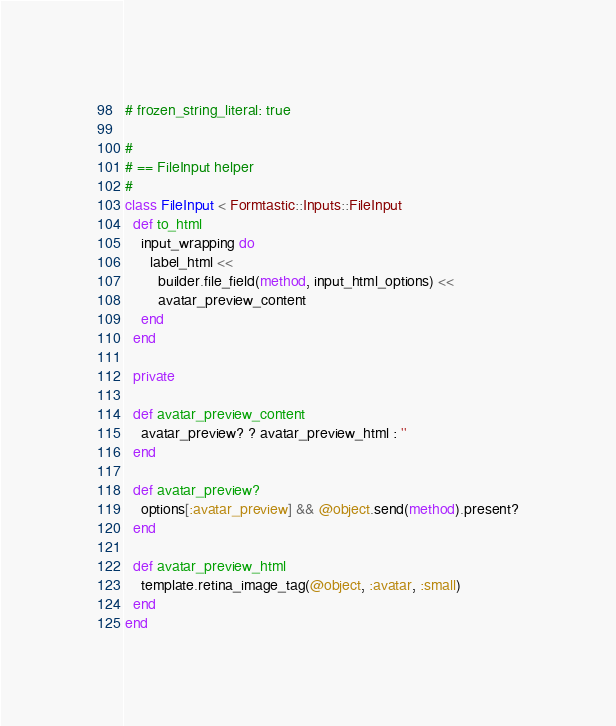Convert code to text. <code><loc_0><loc_0><loc_500><loc_500><_Ruby_># frozen_string_literal: true

#
# == FileInput helper
#
class FileInput < Formtastic::Inputs::FileInput
  def to_html
    input_wrapping do
      label_html <<
        builder.file_field(method, input_html_options) <<
        avatar_preview_content
    end
  end

  private

  def avatar_preview_content
    avatar_preview? ? avatar_preview_html : ''
  end

  def avatar_preview?
    options[:avatar_preview] && @object.send(method).present?
  end

  def avatar_preview_html
    template.retina_image_tag(@object, :avatar, :small)
  end
end
</code> 